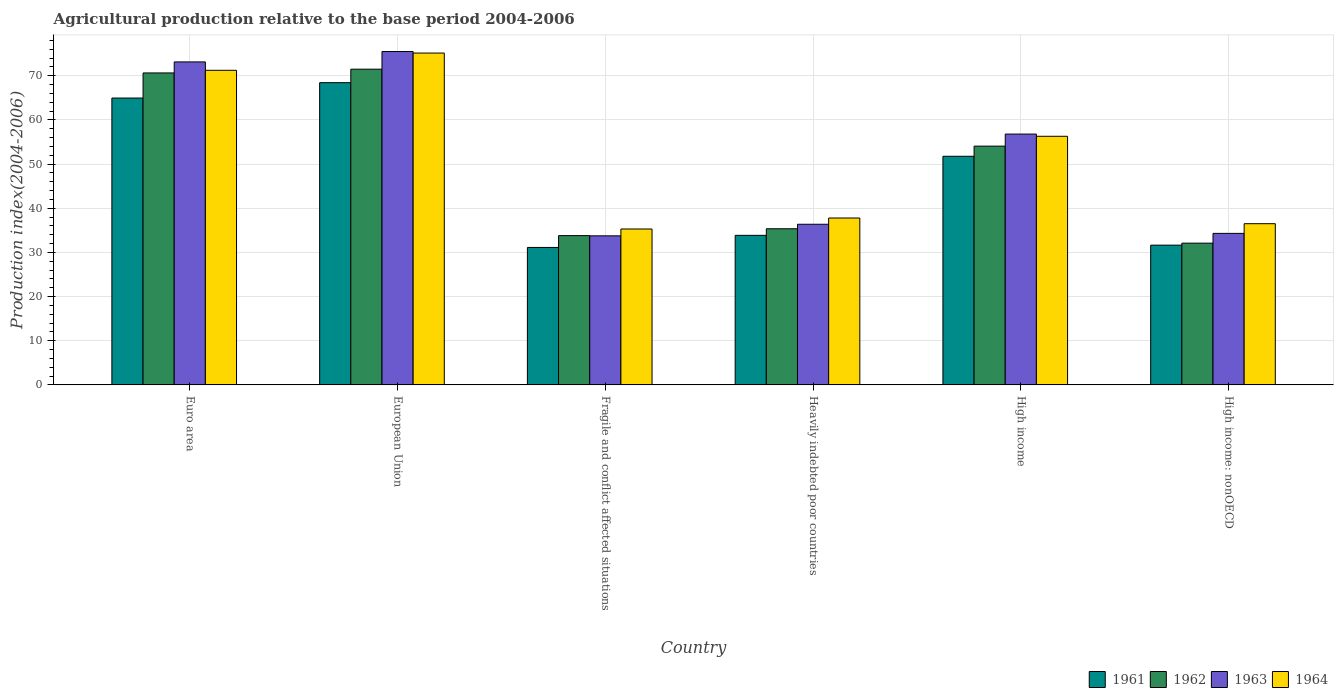In how many cases, is the number of bars for a given country not equal to the number of legend labels?
Provide a short and direct response. 0. What is the agricultural production index in 1963 in High income?
Make the answer very short. 56.8. Across all countries, what is the maximum agricultural production index in 1962?
Offer a very short reply. 71.49. Across all countries, what is the minimum agricultural production index in 1962?
Make the answer very short. 32.1. In which country was the agricultural production index in 1963 minimum?
Offer a terse response. Fragile and conflict affected situations. What is the total agricultural production index in 1962 in the graph?
Your response must be concise. 297.47. What is the difference between the agricultural production index in 1962 in Euro area and that in Fragile and conflict affected situations?
Offer a terse response. 36.83. What is the difference between the agricultural production index in 1961 in European Union and the agricultural production index in 1962 in Fragile and conflict affected situations?
Your answer should be compact. 34.64. What is the average agricultural production index in 1964 per country?
Offer a very short reply. 52.05. What is the difference between the agricultural production index of/in 1961 and agricultural production index of/in 1964 in Heavily indebted poor countries?
Give a very brief answer. -3.92. What is the ratio of the agricultural production index in 1961 in Euro area to that in Fragile and conflict affected situations?
Give a very brief answer. 2.09. Is the agricultural production index in 1962 in Fragile and conflict affected situations less than that in High income?
Keep it short and to the point. Yes. What is the difference between the highest and the second highest agricultural production index in 1963?
Keep it short and to the point. -16.34. What is the difference between the highest and the lowest agricultural production index in 1964?
Make the answer very short. 39.84. In how many countries, is the agricultural production index in 1963 greater than the average agricultural production index in 1963 taken over all countries?
Provide a short and direct response. 3. Is it the case that in every country, the sum of the agricultural production index in 1962 and agricultural production index in 1964 is greater than the sum of agricultural production index in 1961 and agricultural production index in 1963?
Your answer should be compact. No. What does the 4th bar from the left in Fragile and conflict affected situations represents?
Your response must be concise. 1964. What does the 1st bar from the right in Fragile and conflict affected situations represents?
Provide a short and direct response. 1964. Are all the bars in the graph horizontal?
Your answer should be compact. No. Does the graph contain grids?
Provide a succinct answer. Yes. What is the title of the graph?
Ensure brevity in your answer.  Agricultural production relative to the base period 2004-2006. Does "2009" appear as one of the legend labels in the graph?
Keep it short and to the point. No. What is the label or title of the X-axis?
Give a very brief answer. Country. What is the label or title of the Y-axis?
Offer a terse response. Production index(2004-2006). What is the Production index(2004-2006) of 1961 in Euro area?
Offer a very short reply. 64.96. What is the Production index(2004-2006) of 1962 in Euro area?
Make the answer very short. 70.64. What is the Production index(2004-2006) of 1963 in Euro area?
Your answer should be very brief. 73.14. What is the Production index(2004-2006) in 1964 in Euro area?
Ensure brevity in your answer.  71.24. What is the Production index(2004-2006) in 1961 in European Union?
Give a very brief answer. 68.44. What is the Production index(2004-2006) of 1962 in European Union?
Ensure brevity in your answer.  71.49. What is the Production index(2004-2006) of 1963 in European Union?
Provide a short and direct response. 75.49. What is the Production index(2004-2006) of 1964 in European Union?
Your answer should be very brief. 75.15. What is the Production index(2004-2006) of 1961 in Fragile and conflict affected situations?
Provide a short and direct response. 31.13. What is the Production index(2004-2006) of 1962 in Fragile and conflict affected situations?
Your response must be concise. 33.81. What is the Production index(2004-2006) in 1963 in Fragile and conflict affected situations?
Keep it short and to the point. 33.76. What is the Production index(2004-2006) of 1964 in Fragile and conflict affected situations?
Offer a terse response. 35.31. What is the Production index(2004-2006) in 1961 in Heavily indebted poor countries?
Your answer should be compact. 33.87. What is the Production index(2004-2006) in 1962 in Heavily indebted poor countries?
Provide a short and direct response. 35.36. What is the Production index(2004-2006) in 1963 in Heavily indebted poor countries?
Provide a succinct answer. 36.38. What is the Production index(2004-2006) in 1964 in Heavily indebted poor countries?
Keep it short and to the point. 37.79. What is the Production index(2004-2006) of 1961 in High income?
Your answer should be very brief. 51.77. What is the Production index(2004-2006) of 1962 in High income?
Provide a short and direct response. 54.07. What is the Production index(2004-2006) of 1963 in High income?
Your answer should be very brief. 56.8. What is the Production index(2004-2006) in 1964 in High income?
Your answer should be very brief. 56.3. What is the Production index(2004-2006) of 1961 in High income: nonOECD?
Your response must be concise. 31.65. What is the Production index(2004-2006) in 1962 in High income: nonOECD?
Your answer should be compact. 32.1. What is the Production index(2004-2006) of 1963 in High income: nonOECD?
Provide a short and direct response. 34.31. What is the Production index(2004-2006) of 1964 in High income: nonOECD?
Your answer should be very brief. 36.51. Across all countries, what is the maximum Production index(2004-2006) of 1961?
Ensure brevity in your answer.  68.44. Across all countries, what is the maximum Production index(2004-2006) of 1962?
Your response must be concise. 71.49. Across all countries, what is the maximum Production index(2004-2006) of 1963?
Ensure brevity in your answer.  75.49. Across all countries, what is the maximum Production index(2004-2006) in 1964?
Offer a very short reply. 75.15. Across all countries, what is the minimum Production index(2004-2006) of 1961?
Ensure brevity in your answer.  31.13. Across all countries, what is the minimum Production index(2004-2006) in 1962?
Your answer should be compact. 32.1. Across all countries, what is the minimum Production index(2004-2006) of 1963?
Your response must be concise. 33.76. Across all countries, what is the minimum Production index(2004-2006) of 1964?
Ensure brevity in your answer.  35.31. What is the total Production index(2004-2006) in 1961 in the graph?
Make the answer very short. 281.82. What is the total Production index(2004-2006) of 1962 in the graph?
Give a very brief answer. 297.47. What is the total Production index(2004-2006) in 1963 in the graph?
Offer a terse response. 309.88. What is the total Production index(2004-2006) in 1964 in the graph?
Your answer should be compact. 312.29. What is the difference between the Production index(2004-2006) of 1961 in Euro area and that in European Union?
Offer a very short reply. -3.48. What is the difference between the Production index(2004-2006) of 1962 in Euro area and that in European Union?
Your answer should be very brief. -0.85. What is the difference between the Production index(2004-2006) in 1963 in Euro area and that in European Union?
Offer a terse response. -2.35. What is the difference between the Production index(2004-2006) of 1964 in Euro area and that in European Union?
Keep it short and to the point. -3.9. What is the difference between the Production index(2004-2006) of 1961 in Euro area and that in Fragile and conflict affected situations?
Keep it short and to the point. 33.83. What is the difference between the Production index(2004-2006) in 1962 in Euro area and that in Fragile and conflict affected situations?
Give a very brief answer. 36.83. What is the difference between the Production index(2004-2006) in 1963 in Euro area and that in Fragile and conflict affected situations?
Your response must be concise. 39.38. What is the difference between the Production index(2004-2006) of 1964 in Euro area and that in Fragile and conflict affected situations?
Make the answer very short. 35.94. What is the difference between the Production index(2004-2006) in 1961 in Euro area and that in Heavily indebted poor countries?
Your answer should be compact. 31.09. What is the difference between the Production index(2004-2006) of 1962 in Euro area and that in Heavily indebted poor countries?
Ensure brevity in your answer.  35.28. What is the difference between the Production index(2004-2006) of 1963 in Euro area and that in Heavily indebted poor countries?
Ensure brevity in your answer.  36.76. What is the difference between the Production index(2004-2006) of 1964 in Euro area and that in Heavily indebted poor countries?
Give a very brief answer. 33.45. What is the difference between the Production index(2004-2006) in 1961 in Euro area and that in High income?
Ensure brevity in your answer.  13.19. What is the difference between the Production index(2004-2006) of 1962 in Euro area and that in High income?
Provide a succinct answer. 16.57. What is the difference between the Production index(2004-2006) of 1963 in Euro area and that in High income?
Provide a short and direct response. 16.34. What is the difference between the Production index(2004-2006) in 1964 in Euro area and that in High income?
Provide a succinct answer. 14.94. What is the difference between the Production index(2004-2006) in 1961 in Euro area and that in High income: nonOECD?
Give a very brief answer. 33.31. What is the difference between the Production index(2004-2006) of 1962 in Euro area and that in High income: nonOECD?
Your answer should be very brief. 38.54. What is the difference between the Production index(2004-2006) of 1963 in Euro area and that in High income: nonOECD?
Your answer should be compact. 38.83. What is the difference between the Production index(2004-2006) of 1964 in Euro area and that in High income: nonOECD?
Your response must be concise. 34.73. What is the difference between the Production index(2004-2006) of 1961 in European Union and that in Fragile and conflict affected situations?
Your answer should be compact. 37.32. What is the difference between the Production index(2004-2006) of 1962 in European Union and that in Fragile and conflict affected situations?
Offer a very short reply. 37.69. What is the difference between the Production index(2004-2006) in 1963 in European Union and that in Fragile and conflict affected situations?
Offer a very short reply. 41.73. What is the difference between the Production index(2004-2006) of 1964 in European Union and that in Fragile and conflict affected situations?
Keep it short and to the point. 39.84. What is the difference between the Production index(2004-2006) in 1961 in European Union and that in Heavily indebted poor countries?
Provide a short and direct response. 34.57. What is the difference between the Production index(2004-2006) in 1962 in European Union and that in Heavily indebted poor countries?
Make the answer very short. 36.13. What is the difference between the Production index(2004-2006) in 1963 in European Union and that in Heavily indebted poor countries?
Ensure brevity in your answer.  39.11. What is the difference between the Production index(2004-2006) of 1964 in European Union and that in Heavily indebted poor countries?
Give a very brief answer. 37.35. What is the difference between the Production index(2004-2006) of 1961 in European Union and that in High income?
Give a very brief answer. 16.67. What is the difference between the Production index(2004-2006) of 1962 in European Union and that in High income?
Provide a short and direct response. 17.43. What is the difference between the Production index(2004-2006) of 1963 in European Union and that in High income?
Your answer should be very brief. 18.69. What is the difference between the Production index(2004-2006) in 1964 in European Union and that in High income?
Provide a short and direct response. 18.85. What is the difference between the Production index(2004-2006) in 1961 in European Union and that in High income: nonOECD?
Your answer should be compact. 36.79. What is the difference between the Production index(2004-2006) in 1962 in European Union and that in High income: nonOECD?
Your answer should be compact. 39.39. What is the difference between the Production index(2004-2006) of 1963 in European Union and that in High income: nonOECD?
Provide a short and direct response. 41.17. What is the difference between the Production index(2004-2006) in 1964 in European Union and that in High income: nonOECD?
Your response must be concise. 38.64. What is the difference between the Production index(2004-2006) in 1961 in Fragile and conflict affected situations and that in Heavily indebted poor countries?
Provide a succinct answer. -2.74. What is the difference between the Production index(2004-2006) of 1962 in Fragile and conflict affected situations and that in Heavily indebted poor countries?
Ensure brevity in your answer.  -1.55. What is the difference between the Production index(2004-2006) of 1963 in Fragile and conflict affected situations and that in Heavily indebted poor countries?
Your answer should be very brief. -2.62. What is the difference between the Production index(2004-2006) in 1964 in Fragile and conflict affected situations and that in Heavily indebted poor countries?
Ensure brevity in your answer.  -2.49. What is the difference between the Production index(2004-2006) in 1961 in Fragile and conflict affected situations and that in High income?
Provide a short and direct response. -20.65. What is the difference between the Production index(2004-2006) of 1962 in Fragile and conflict affected situations and that in High income?
Make the answer very short. -20.26. What is the difference between the Production index(2004-2006) in 1963 in Fragile and conflict affected situations and that in High income?
Your answer should be very brief. -23.04. What is the difference between the Production index(2004-2006) of 1964 in Fragile and conflict affected situations and that in High income?
Keep it short and to the point. -20.99. What is the difference between the Production index(2004-2006) of 1961 in Fragile and conflict affected situations and that in High income: nonOECD?
Provide a succinct answer. -0.52. What is the difference between the Production index(2004-2006) in 1962 in Fragile and conflict affected situations and that in High income: nonOECD?
Provide a short and direct response. 1.7. What is the difference between the Production index(2004-2006) in 1963 in Fragile and conflict affected situations and that in High income: nonOECD?
Make the answer very short. -0.56. What is the difference between the Production index(2004-2006) of 1964 in Fragile and conflict affected situations and that in High income: nonOECD?
Make the answer very short. -1.2. What is the difference between the Production index(2004-2006) in 1961 in Heavily indebted poor countries and that in High income?
Your answer should be compact. -17.91. What is the difference between the Production index(2004-2006) in 1962 in Heavily indebted poor countries and that in High income?
Keep it short and to the point. -18.71. What is the difference between the Production index(2004-2006) of 1963 in Heavily indebted poor countries and that in High income?
Keep it short and to the point. -20.42. What is the difference between the Production index(2004-2006) of 1964 in Heavily indebted poor countries and that in High income?
Keep it short and to the point. -18.5. What is the difference between the Production index(2004-2006) of 1961 in Heavily indebted poor countries and that in High income: nonOECD?
Your response must be concise. 2.22. What is the difference between the Production index(2004-2006) in 1962 in Heavily indebted poor countries and that in High income: nonOECD?
Provide a succinct answer. 3.26. What is the difference between the Production index(2004-2006) in 1963 in Heavily indebted poor countries and that in High income: nonOECD?
Offer a very short reply. 2.07. What is the difference between the Production index(2004-2006) of 1964 in Heavily indebted poor countries and that in High income: nonOECD?
Ensure brevity in your answer.  1.29. What is the difference between the Production index(2004-2006) of 1961 in High income and that in High income: nonOECD?
Offer a terse response. 20.12. What is the difference between the Production index(2004-2006) in 1962 in High income and that in High income: nonOECD?
Keep it short and to the point. 21.97. What is the difference between the Production index(2004-2006) in 1963 in High income and that in High income: nonOECD?
Offer a terse response. 22.49. What is the difference between the Production index(2004-2006) in 1964 in High income and that in High income: nonOECD?
Provide a short and direct response. 19.79. What is the difference between the Production index(2004-2006) in 1961 in Euro area and the Production index(2004-2006) in 1962 in European Union?
Offer a very short reply. -6.54. What is the difference between the Production index(2004-2006) of 1961 in Euro area and the Production index(2004-2006) of 1963 in European Union?
Provide a succinct answer. -10.53. What is the difference between the Production index(2004-2006) of 1961 in Euro area and the Production index(2004-2006) of 1964 in European Union?
Ensure brevity in your answer.  -10.19. What is the difference between the Production index(2004-2006) in 1962 in Euro area and the Production index(2004-2006) in 1963 in European Union?
Your response must be concise. -4.85. What is the difference between the Production index(2004-2006) of 1962 in Euro area and the Production index(2004-2006) of 1964 in European Union?
Provide a short and direct response. -4.5. What is the difference between the Production index(2004-2006) of 1963 in Euro area and the Production index(2004-2006) of 1964 in European Union?
Offer a terse response. -2.01. What is the difference between the Production index(2004-2006) of 1961 in Euro area and the Production index(2004-2006) of 1962 in Fragile and conflict affected situations?
Your answer should be very brief. 31.15. What is the difference between the Production index(2004-2006) of 1961 in Euro area and the Production index(2004-2006) of 1963 in Fragile and conflict affected situations?
Your answer should be compact. 31.2. What is the difference between the Production index(2004-2006) in 1961 in Euro area and the Production index(2004-2006) in 1964 in Fragile and conflict affected situations?
Ensure brevity in your answer.  29.65. What is the difference between the Production index(2004-2006) in 1962 in Euro area and the Production index(2004-2006) in 1963 in Fragile and conflict affected situations?
Your answer should be compact. 36.88. What is the difference between the Production index(2004-2006) in 1962 in Euro area and the Production index(2004-2006) in 1964 in Fragile and conflict affected situations?
Give a very brief answer. 35.34. What is the difference between the Production index(2004-2006) in 1963 in Euro area and the Production index(2004-2006) in 1964 in Fragile and conflict affected situations?
Provide a short and direct response. 37.83. What is the difference between the Production index(2004-2006) in 1961 in Euro area and the Production index(2004-2006) in 1962 in Heavily indebted poor countries?
Offer a very short reply. 29.6. What is the difference between the Production index(2004-2006) of 1961 in Euro area and the Production index(2004-2006) of 1963 in Heavily indebted poor countries?
Offer a terse response. 28.58. What is the difference between the Production index(2004-2006) of 1961 in Euro area and the Production index(2004-2006) of 1964 in Heavily indebted poor countries?
Keep it short and to the point. 27.17. What is the difference between the Production index(2004-2006) of 1962 in Euro area and the Production index(2004-2006) of 1963 in Heavily indebted poor countries?
Keep it short and to the point. 34.26. What is the difference between the Production index(2004-2006) of 1962 in Euro area and the Production index(2004-2006) of 1964 in Heavily indebted poor countries?
Keep it short and to the point. 32.85. What is the difference between the Production index(2004-2006) of 1963 in Euro area and the Production index(2004-2006) of 1964 in Heavily indebted poor countries?
Your answer should be compact. 35.35. What is the difference between the Production index(2004-2006) in 1961 in Euro area and the Production index(2004-2006) in 1962 in High income?
Make the answer very short. 10.89. What is the difference between the Production index(2004-2006) in 1961 in Euro area and the Production index(2004-2006) in 1963 in High income?
Provide a succinct answer. 8.16. What is the difference between the Production index(2004-2006) in 1961 in Euro area and the Production index(2004-2006) in 1964 in High income?
Your response must be concise. 8.66. What is the difference between the Production index(2004-2006) of 1962 in Euro area and the Production index(2004-2006) of 1963 in High income?
Your response must be concise. 13.84. What is the difference between the Production index(2004-2006) of 1962 in Euro area and the Production index(2004-2006) of 1964 in High income?
Your response must be concise. 14.34. What is the difference between the Production index(2004-2006) in 1963 in Euro area and the Production index(2004-2006) in 1964 in High income?
Your answer should be very brief. 16.84. What is the difference between the Production index(2004-2006) of 1961 in Euro area and the Production index(2004-2006) of 1962 in High income: nonOECD?
Ensure brevity in your answer.  32.86. What is the difference between the Production index(2004-2006) of 1961 in Euro area and the Production index(2004-2006) of 1963 in High income: nonOECD?
Your response must be concise. 30.65. What is the difference between the Production index(2004-2006) of 1961 in Euro area and the Production index(2004-2006) of 1964 in High income: nonOECD?
Offer a terse response. 28.45. What is the difference between the Production index(2004-2006) in 1962 in Euro area and the Production index(2004-2006) in 1963 in High income: nonOECD?
Offer a terse response. 36.33. What is the difference between the Production index(2004-2006) of 1962 in Euro area and the Production index(2004-2006) of 1964 in High income: nonOECD?
Provide a succinct answer. 34.13. What is the difference between the Production index(2004-2006) of 1963 in Euro area and the Production index(2004-2006) of 1964 in High income: nonOECD?
Your answer should be very brief. 36.63. What is the difference between the Production index(2004-2006) of 1961 in European Union and the Production index(2004-2006) of 1962 in Fragile and conflict affected situations?
Offer a very short reply. 34.64. What is the difference between the Production index(2004-2006) in 1961 in European Union and the Production index(2004-2006) in 1963 in Fragile and conflict affected situations?
Provide a succinct answer. 34.69. What is the difference between the Production index(2004-2006) in 1961 in European Union and the Production index(2004-2006) in 1964 in Fragile and conflict affected situations?
Ensure brevity in your answer.  33.14. What is the difference between the Production index(2004-2006) in 1962 in European Union and the Production index(2004-2006) in 1963 in Fragile and conflict affected situations?
Provide a short and direct response. 37.74. What is the difference between the Production index(2004-2006) of 1962 in European Union and the Production index(2004-2006) of 1964 in Fragile and conflict affected situations?
Your answer should be very brief. 36.19. What is the difference between the Production index(2004-2006) in 1963 in European Union and the Production index(2004-2006) in 1964 in Fragile and conflict affected situations?
Ensure brevity in your answer.  40.18. What is the difference between the Production index(2004-2006) in 1961 in European Union and the Production index(2004-2006) in 1962 in Heavily indebted poor countries?
Keep it short and to the point. 33.08. What is the difference between the Production index(2004-2006) of 1961 in European Union and the Production index(2004-2006) of 1963 in Heavily indebted poor countries?
Ensure brevity in your answer.  32.06. What is the difference between the Production index(2004-2006) of 1961 in European Union and the Production index(2004-2006) of 1964 in Heavily indebted poor countries?
Keep it short and to the point. 30.65. What is the difference between the Production index(2004-2006) in 1962 in European Union and the Production index(2004-2006) in 1963 in Heavily indebted poor countries?
Offer a terse response. 35.12. What is the difference between the Production index(2004-2006) of 1962 in European Union and the Production index(2004-2006) of 1964 in Heavily indebted poor countries?
Make the answer very short. 33.7. What is the difference between the Production index(2004-2006) of 1963 in European Union and the Production index(2004-2006) of 1964 in Heavily indebted poor countries?
Ensure brevity in your answer.  37.69. What is the difference between the Production index(2004-2006) in 1961 in European Union and the Production index(2004-2006) in 1962 in High income?
Make the answer very short. 14.37. What is the difference between the Production index(2004-2006) of 1961 in European Union and the Production index(2004-2006) of 1963 in High income?
Give a very brief answer. 11.64. What is the difference between the Production index(2004-2006) in 1961 in European Union and the Production index(2004-2006) in 1964 in High income?
Your response must be concise. 12.15. What is the difference between the Production index(2004-2006) of 1962 in European Union and the Production index(2004-2006) of 1963 in High income?
Ensure brevity in your answer.  14.69. What is the difference between the Production index(2004-2006) of 1962 in European Union and the Production index(2004-2006) of 1964 in High income?
Make the answer very short. 15.2. What is the difference between the Production index(2004-2006) in 1963 in European Union and the Production index(2004-2006) in 1964 in High income?
Offer a terse response. 19.19. What is the difference between the Production index(2004-2006) of 1961 in European Union and the Production index(2004-2006) of 1962 in High income: nonOECD?
Give a very brief answer. 36.34. What is the difference between the Production index(2004-2006) of 1961 in European Union and the Production index(2004-2006) of 1963 in High income: nonOECD?
Offer a terse response. 34.13. What is the difference between the Production index(2004-2006) of 1961 in European Union and the Production index(2004-2006) of 1964 in High income: nonOECD?
Keep it short and to the point. 31.94. What is the difference between the Production index(2004-2006) in 1962 in European Union and the Production index(2004-2006) in 1963 in High income: nonOECD?
Offer a very short reply. 37.18. What is the difference between the Production index(2004-2006) of 1962 in European Union and the Production index(2004-2006) of 1964 in High income: nonOECD?
Provide a short and direct response. 34.99. What is the difference between the Production index(2004-2006) of 1963 in European Union and the Production index(2004-2006) of 1964 in High income: nonOECD?
Offer a terse response. 38.98. What is the difference between the Production index(2004-2006) of 1961 in Fragile and conflict affected situations and the Production index(2004-2006) of 1962 in Heavily indebted poor countries?
Offer a very short reply. -4.23. What is the difference between the Production index(2004-2006) in 1961 in Fragile and conflict affected situations and the Production index(2004-2006) in 1963 in Heavily indebted poor countries?
Ensure brevity in your answer.  -5.25. What is the difference between the Production index(2004-2006) in 1961 in Fragile and conflict affected situations and the Production index(2004-2006) in 1964 in Heavily indebted poor countries?
Make the answer very short. -6.67. What is the difference between the Production index(2004-2006) of 1962 in Fragile and conflict affected situations and the Production index(2004-2006) of 1963 in Heavily indebted poor countries?
Your answer should be very brief. -2.57. What is the difference between the Production index(2004-2006) of 1962 in Fragile and conflict affected situations and the Production index(2004-2006) of 1964 in Heavily indebted poor countries?
Your answer should be compact. -3.99. What is the difference between the Production index(2004-2006) of 1963 in Fragile and conflict affected situations and the Production index(2004-2006) of 1964 in Heavily indebted poor countries?
Give a very brief answer. -4.04. What is the difference between the Production index(2004-2006) in 1961 in Fragile and conflict affected situations and the Production index(2004-2006) in 1962 in High income?
Your response must be concise. -22.94. What is the difference between the Production index(2004-2006) of 1961 in Fragile and conflict affected situations and the Production index(2004-2006) of 1963 in High income?
Provide a succinct answer. -25.67. What is the difference between the Production index(2004-2006) of 1961 in Fragile and conflict affected situations and the Production index(2004-2006) of 1964 in High income?
Keep it short and to the point. -25.17. What is the difference between the Production index(2004-2006) of 1962 in Fragile and conflict affected situations and the Production index(2004-2006) of 1963 in High income?
Your response must be concise. -22.99. What is the difference between the Production index(2004-2006) in 1962 in Fragile and conflict affected situations and the Production index(2004-2006) in 1964 in High income?
Ensure brevity in your answer.  -22.49. What is the difference between the Production index(2004-2006) of 1963 in Fragile and conflict affected situations and the Production index(2004-2006) of 1964 in High income?
Keep it short and to the point. -22.54. What is the difference between the Production index(2004-2006) in 1961 in Fragile and conflict affected situations and the Production index(2004-2006) in 1962 in High income: nonOECD?
Give a very brief answer. -0.97. What is the difference between the Production index(2004-2006) of 1961 in Fragile and conflict affected situations and the Production index(2004-2006) of 1963 in High income: nonOECD?
Ensure brevity in your answer.  -3.19. What is the difference between the Production index(2004-2006) of 1961 in Fragile and conflict affected situations and the Production index(2004-2006) of 1964 in High income: nonOECD?
Ensure brevity in your answer.  -5.38. What is the difference between the Production index(2004-2006) of 1962 in Fragile and conflict affected situations and the Production index(2004-2006) of 1963 in High income: nonOECD?
Keep it short and to the point. -0.51. What is the difference between the Production index(2004-2006) of 1962 in Fragile and conflict affected situations and the Production index(2004-2006) of 1964 in High income: nonOECD?
Your answer should be compact. -2.7. What is the difference between the Production index(2004-2006) of 1963 in Fragile and conflict affected situations and the Production index(2004-2006) of 1964 in High income: nonOECD?
Offer a very short reply. -2.75. What is the difference between the Production index(2004-2006) in 1961 in Heavily indebted poor countries and the Production index(2004-2006) in 1962 in High income?
Give a very brief answer. -20.2. What is the difference between the Production index(2004-2006) in 1961 in Heavily indebted poor countries and the Production index(2004-2006) in 1963 in High income?
Provide a succinct answer. -22.93. What is the difference between the Production index(2004-2006) of 1961 in Heavily indebted poor countries and the Production index(2004-2006) of 1964 in High income?
Provide a short and direct response. -22.43. What is the difference between the Production index(2004-2006) in 1962 in Heavily indebted poor countries and the Production index(2004-2006) in 1963 in High income?
Your answer should be compact. -21.44. What is the difference between the Production index(2004-2006) in 1962 in Heavily indebted poor countries and the Production index(2004-2006) in 1964 in High income?
Provide a short and direct response. -20.94. What is the difference between the Production index(2004-2006) of 1963 in Heavily indebted poor countries and the Production index(2004-2006) of 1964 in High income?
Offer a very short reply. -19.92. What is the difference between the Production index(2004-2006) in 1961 in Heavily indebted poor countries and the Production index(2004-2006) in 1962 in High income: nonOECD?
Your response must be concise. 1.77. What is the difference between the Production index(2004-2006) of 1961 in Heavily indebted poor countries and the Production index(2004-2006) of 1963 in High income: nonOECD?
Ensure brevity in your answer.  -0.44. What is the difference between the Production index(2004-2006) in 1961 in Heavily indebted poor countries and the Production index(2004-2006) in 1964 in High income: nonOECD?
Keep it short and to the point. -2.64. What is the difference between the Production index(2004-2006) of 1962 in Heavily indebted poor countries and the Production index(2004-2006) of 1963 in High income: nonOECD?
Offer a terse response. 1.05. What is the difference between the Production index(2004-2006) in 1962 in Heavily indebted poor countries and the Production index(2004-2006) in 1964 in High income: nonOECD?
Your response must be concise. -1.15. What is the difference between the Production index(2004-2006) of 1963 in Heavily indebted poor countries and the Production index(2004-2006) of 1964 in High income: nonOECD?
Ensure brevity in your answer.  -0.13. What is the difference between the Production index(2004-2006) of 1961 in High income and the Production index(2004-2006) of 1962 in High income: nonOECD?
Make the answer very short. 19.67. What is the difference between the Production index(2004-2006) in 1961 in High income and the Production index(2004-2006) in 1963 in High income: nonOECD?
Ensure brevity in your answer.  17.46. What is the difference between the Production index(2004-2006) of 1961 in High income and the Production index(2004-2006) of 1964 in High income: nonOECD?
Give a very brief answer. 15.27. What is the difference between the Production index(2004-2006) in 1962 in High income and the Production index(2004-2006) in 1963 in High income: nonOECD?
Ensure brevity in your answer.  19.76. What is the difference between the Production index(2004-2006) in 1962 in High income and the Production index(2004-2006) in 1964 in High income: nonOECD?
Your response must be concise. 17.56. What is the difference between the Production index(2004-2006) of 1963 in High income and the Production index(2004-2006) of 1964 in High income: nonOECD?
Your answer should be very brief. 20.29. What is the average Production index(2004-2006) of 1961 per country?
Ensure brevity in your answer.  46.97. What is the average Production index(2004-2006) in 1962 per country?
Offer a terse response. 49.58. What is the average Production index(2004-2006) in 1963 per country?
Ensure brevity in your answer.  51.65. What is the average Production index(2004-2006) of 1964 per country?
Offer a terse response. 52.05. What is the difference between the Production index(2004-2006) of 1961 and Production index(2004-2006) of 1962 in Euro area?
Provide a short and direct response. -5.68. What is the difference between the Production index(2004-2006) in 1961 and Production index(2004-2006) in 1963 in Euro area?
Your answer should be compact. -8.18. What is the difference between the Production index(2004-2006) in 1961 and Production index(2004-2006) in 1964 in Euro area?
Keep it short and to the point. -6.28. What is the difference between the Production index(2004-2006) in 1962 and Production index(2004-2006) in 1963 in Euro area?
Ensure brevity in your answer.  -2.5. What is the difference between the Production index(2004-2006) in 1962 and Production index(2004-2006) in 1964 in Euro area?
Provide a short and direct response. -0.6. What is the difference between the Production index(2004-2006) in 1963 and Production index(2004-2006) in 1964 in Euro area?
Provide a short and direct response. 1.9. What is the difference between the Production index(2004-2006) of 1961 and Production index(2004-2006) of 1962 in European Union?
Your answer should be very brief. -3.05. What is the difference between the Production index(2004-2006) of 1961 and Production index(2004-2006) of 1963 in European Union?
Offer a very short reply. -7.05. What is the difference between the Production index(2004-2006) of 1961 and Production index(2004-2006) of 1964 in European Union?
Offer a terse response. -6.7. What is the difference between the Production index(2004-2006) of 1962 and Production index(2004-2006) of 1963 in European Union?
Offer a terse response. -3.99. What is the difference between the Production index(2004-2006) of 1962 and Production index(2004-2006) of 1964 in European Union?
Your answer should be very brief. -3.65. What is the difference between the Production index(2004-2006) of 1963 and Production index(2004-2006) of 1964 in European Union?
Your answer should be very brief. 0.34. What is the difference between the Production index(2004-2006) in 1961 and Production index(2004-2006) in 1962 in Fragile and conflict affected situations?
Your answer should be compact. -2.68. What is the difference between the Production index(2004-2006) in 1961 and Production index(2004-2006) in 1963 in Fragile and conflict affected situations?
Offer a terse response. -2.63. What is the difference between the Production index(2004-2006) in 1961 and Production index(2004-2006) in 1964 in Fragile and conflict affected situations?
Offer a terse response. -4.18. What is the difference between the Production index(2004-2006) of 1962 and Production index(2004-2006) of 1963 in Fragile and conflict affected situations?
Provide a succinct answer. 0.05. What is the difference between the Production index(2004-2006) in 1962 and Production index(2004-2006) in 1964 in Fragile and conflict affected situations?
Provide a succinct answer. -1.5. What is the difference between the Production index(2004-2006) in 1963 and Production index(2004-2006) in 1964 in Fragile and conflict affected situations?
Provide a short and direct response. -1.55. What is the difference between the Production index(2004-2006) of 1961 and Production index(2004-2006) of 1962 in Heavily indebted poor countries?
Offer a very short reply. -1.49. What is the difference between the Production index(2004-2006) in 1961 and Production index(2004-2006) in 1963 in Heavily indebted poor countries?
Offer a terse response. -2.51. What is the difference between the Production index(2004-2006) of 1961 and Production index(2004-2006) of 1964 in Heavily indebted poor countries?
Keep it short and to the point. -3.92. What is the difference between the Production index(2004-2006) of 1962 and Production index(2004-2006) of 1963 in Heavily indebted poor countries?
Offer a terse response. -1.02. What is the difference between the Production index(2004-2006) in 1962 and Production index(2004-2006) in 1964 in Heavily indebted poor countries?
Give a very brief answer. -2.43. What is the difference between the Production index(2004-2006) in 1963 and Production index(2004-2006) in 1964 in Heavily indebted poor countries?
Offer a terse response. -1.42. What is the difference between the Production index(2004-2006) in 1961 and Production index(2004-2006) in 1962 in High income?
Your response must be concise. -2.29. What is the difference between the Production index(2004-2006) in 1961 and Production index(2004-2006) in 1963 in High income?
Keep it short and to the point. -5.03. What is the difference between the Production index(2004-2006) of 1961 and Production index(2004-2006) of 1964 in High income?
Give a very brief answer. -4.52. What is the difference between the Production index(2004-2006) of 1962 and Production index(2004-2006) of 1963 in High income?
Your answer should be compact. -2.73. What is the difference between the Production index(2004-2006) of 1962 and Production index(2004-2006) of 1964 in High income?
Ensure brevity in your answer.  -2.23. What is the difference between the Production index(2004-2006) of 1963 and Production index(2004-2006) of 1964 in High income?
Offer a very short reply. 0.5. What is the difference between the Production index(2004-2006) of 1961 and Production index(2004-2006) of 1962 in High income: nonOECD?
Give a very brief answer. -0.45. What is the difference between the Production index(2004-2006) in 1961 and Production index(2004-2006) in 1963 in High income: nonOECD?
Provide a short and direct response. -2.66. What is the difference between the Production index(2004-2006) of 1961 and Production index(2004-2006) of 1964 in High income: nonOECD?
Offer a terse response. -4.86. What is the difference between the Production index(2004-2006) of 1962 and Production index(2004-2006) of 1963 in High income: nonOECD?
Offer a very short reply. -2.21. What is the difference between the Production index(2004-2006) in 1962 and Production index(2004-2006) in 1964 in High income: nonOECD?
Offer a terse response. -4.41. What is the difference between the Production index(2004-2006) in 1963 and Production index(2004-2006) in 1964 in High income: nonOECD?
Offer a very short reply. -2.19. What is the ratio of the Production index(2004-2006) of 1961 in Euro area to that in European Union?
Make the answer very short. 0.95. What is the ratio of the Production index(2004-2006) in 1962 in Euro area to that in European Union?
Keep it short and to the point. 0.99. What is the ratio of the Production index(2004-2006) in 1963 in Euro area to that in European Union?
Make the answer very short. 0.97. What is the ratio of the Production index(2004-2006) in 1964 in Euro area to that in European Union?
Offer a terse response. 0.95. What is the ratio of the Production index(2004-2006) in 1961 in Euro area to that in Fragile and conflict affected situations?
Ensure brevity in your answer.  2.09. What is the ratio of the Production index(2004-2006) of 1962 in Euro area to that in Fragile and conflict affected situations?
Offer a terse response. 2.09. What is the ratio of the Production index(2004-2006) of 1963 in Euro area to that in Fragile and conflict affected situations?
Make the answer very short. 2.17. What is the ratio of the Production index(2004-2006) of 1964 in Euro area to that in Fragile and conflict affected situations?
Your response must be concise. 2.02. What is the ratio of the Production index(2004-2006) in 1961 in Euro area to that in Heavily indebted poor countries?
Provide a succinct answer. 1.92. What is the ratio of the Production index(2004-2006) of 1962 in Euro area to that in Heavily indebted poor countries?
Your answer should be very brief. 2. What is the ratio of the Production index(2004-2006) of 1963 in Euro area to that in Heavily indebted poor countries?
Ensure brevity in your answer.  2.01. What is the ratio of the Production index(2004-2006) in 1964 in Euro area to that in Heavily indebted poor countries?
Provide a succinct answer. 1.89. What is the ratio of the Production index(2004-2006) in 1961 in Euro area to that in High income?
Your answer should be compact. 1.25. What is the ratio of the Production index(2004-2006) in 1962 in Euro area to that in High income?
Offer a terse response. 1.31. What is the ratio of the Production index(2004-2006) of 1963 in Euro area to that in High income?
Your response must be concise. 1.29. What is the ratio of the Production index(2004-2006) of 1964 in Euro area to that in High income?
Provide a succinct answer. 1.27. What is the ratio of the Production index(2004-2006) in 1961 in Euro area to that in High income: nonOECD?
Offer a terse response. 2.05. What is the ratio of the Production index(2004-2006) in 1962 in Euro area to that in High income: nonOECD?
Provide a succinct answer. 2.2. What is the ratio of the Production index(2004-2006) of 1963 in Euro area to that in High income: nonOECD?
Give a very brief answer. 2.13. What is the ratio of the Production index(2004-2006) in 1964 in Euro area to that in High income: nonOECD?
Keep it short and to the point. 1.95. What is the ratio of the Production index(2004-2006) in 1961 in European Union to that in Fragile and conflict affected situations?
Your answer should be very brief. 2.2. What is the ratio of the Production index(2004-2006) in 1962 in European Union to that in Fragile and conflict affected situations?
Ensure brevity in your answer.  2.11. What is the ratio of the Production index(2004-2006) in 1963 in European Union to that in Fragile and conflict affected situations?
Your answer should be compact. 2.24. What is the ratio of the Production index(2004-2006) of 1964 in European Union to that in Fragile and conflict affected situations?
Keep it short and to the point. 2.13. What is the ratio of the Production index(2004-2006) of 1961 in European Union to that in Heavily indebted poor countries?
Offer a very short reply. 2.02. What is the ratio of the Production index(2004-2006) in 1962 in European Union to that in Heavily indebted poor countries?
Provide a short and direct response. 2.02. What is the ratio of the Production index(2004-2006) of 1963 in European Union to that in Heavily indebted poor countries?
Offer a terse response. 2.08. What is the ratio of the Production index(2004-2006) of 1964 in European Union to that in Heavily indebted poor countries?
Offer a very short reply. 1.99. What is the ratio of the Production index(2004-2006) in 1961 in European Union to that in High income?
Your response must be concise. 1.32. What is the ratio of the Production index(2004-2006) in 1962 in European Union to that in High income?
Offer a very short reply. 1.32. What is the ratio of the Production index(2004-2006) in 1963 in European Union to that in High income?
Your answer should be compact. 1.33. What is the ratio of the Production index(2004-2006) of 1964 in European Union to that in High income?
Your answer should be compact. 1.33. What is the ratio of the Production index(2004-2006) of 1961 in European Union to that in High income: nonOECD?
Your response must be concise. 2.16. What is the ratio of the Production index(2004-2006) in 1962 in European Union to that in High income: nonOECD?
Offer a very short reply. 2.23. What is the ratio of the Production index(2004-2006) in 1963 in European Union to that in High income: nonOECD?
Your response must be concise. 2.2. What is the ratio of the Production index(2004-2006) of 1964 in European Union to that in High income: nonOECD?
Your answer should be very brief. 2.06. What is the ratio of the Production index(2004-2006) of 1961 in Fragile and conflict affected situations to that in Heavily indebted poor countries?
Provide a short and direct response. 0.92. What is the ratio of the Production index(2004-2006) of 1962 in Fragile and conflict affected situations to that in Heavily indebted poor countries?
Provide a short and direct response. 0.96. What is the ratio of the Production index(2004-2006) of 1963 in Fragile and conflict affected situations to that in Heavily indebted poor countries?
Your answer should be very brief. 0.93. What is the ratio of the Production index(2004-2006) of 1964 in Fragile and conflict affected situations to that in Heavily indebted poor countries?
Give a very brief answer. 0.93. What is the ratio of the Production index(2004-2006) in 1961 in Fragile and conflict affected situations to that in High income?
Your response must be concise. 0.6. What is the ratio of the Production index(2004-2006) in 1962 in Fragile and conflict affected situations to that in High income?
Provide a succinct answer. 0.63. What is the ratio of the Production index(2004-2006) of 1963 in Fragile and conflict affected situations to that in High income?
Offer a terse response. 0.59. What is the ratio of the Production index(2004-2006) in 1964 in Fragile and conflict affected situations to that in High income?
Give a very brief answer. 0.63. What is the ratio of the Production index(2004-2006) of 1961 in Fragile and conflict affected situations to that in High income: nonOECD?
Give a very brief answer. 0.98. What is the ratio of the Production index(2004-2006) of 1962 in Fragile and conflict affected situations to that in High income: nonOECD?
Offer a very short reply. 1.05. What is the ratio of the Production index(2004-2006) of 1963 in Fragile and conflict affected situations to that in High income: nonOECD?
Provide a succinct answer. 0.98. What is the ratio of the Production index(2004-2006) in 1964 in Fragile and conflict affected situations to that in High income: nonOECD?
Ensure brevity in your answer.  0.97. What is the ratio of the Production index(2004-2006) in 1961 in Heavily indebted poor countries to that in High income?
Your response must be concise. 0.65. What is the ratio of the Production index(2004-2006) of 1962 in Heavily indebted poor countries to that in High income?
Your answer should be very brief. 0.65. What is the ratio of the Production index(2004-2006) of 1963 in Heavily indebted poor countries to that in High income?
Make the answer very short. 0.64. What is the ratio of the Production index(2004-2006) in 1964 in Heavily indebted poor countries to that in High income?
Keep it short and to the point. 0.67. What is the ratio of the Production index(2004-2006) in 1961 in Heavily indebted poor countries to that in High income: nonOECD?
Give a very brief answer. 1.07. What is the ratio of the Production index(2004-2006) of 1962 in Heavily indebted poor countries to that in High income: nonOECD?
Offer a terse response. 1.1. What is the ratio of the Production index(2004-2006) of 1963 in Heavily indebted poor countries to that in High income: nonOECD?
Make the answer very short. 1.06. What is the ratio of the Production index(2004-2006) of 1964 in Heavily indebted poor countries to that in High income: nonOECD?
Provide a succinct answer. 1.04. What is the ratio of the Production index(2004-2006) in 1961 in High income to that in High income: nonOECD?
Your answer should be compact. 1.64. What is the ratio of the Production index(2004-2006) in 1962 in High income to that in High income: nonOECD?
Offer a terse response. 1.68. What is the ratio of the Production index(2004-2006) of 1963 in High income to that in High income: nonOECD?
Make the answer very short. 1.66. What is the ratio of the Production index(2004-2006) in 1964 in High income to that in High income: nonOECD?
Offer a very short reply. 1.54. What is the difference between the highest and the second highest Production index(2004-2006) of 1961?
Offer a terse response. 3.48. What is the difference between the highest and the second highest Production index(2004-2006) of 1962?
Offer a terse response. 0.85. What is the difference between the highest and the second highest Production index(2004-2006) of 1963?
Make the answer very short. 2.35. What is the difference between the highest and the second highest Production index(2004-2006) in 1964?
Your answer should be very brief. 3.9. What is the difference between the highest and the lowest Production index(2004-2006) in 1961?
Your answer should be very brief. 37.32. What is the difference between the highest and the lowest Production index(2004-2006) of 1962?
Offer a very short reply. 39.39. What is the difference between the highest and the lowest Production index(2004-2006) in 1963?
Offer a terse response. 41.73. What is the difference between the highest and the lowest Production index(2004-2006) of 1964?
Your answer should be compact. 39.84. 